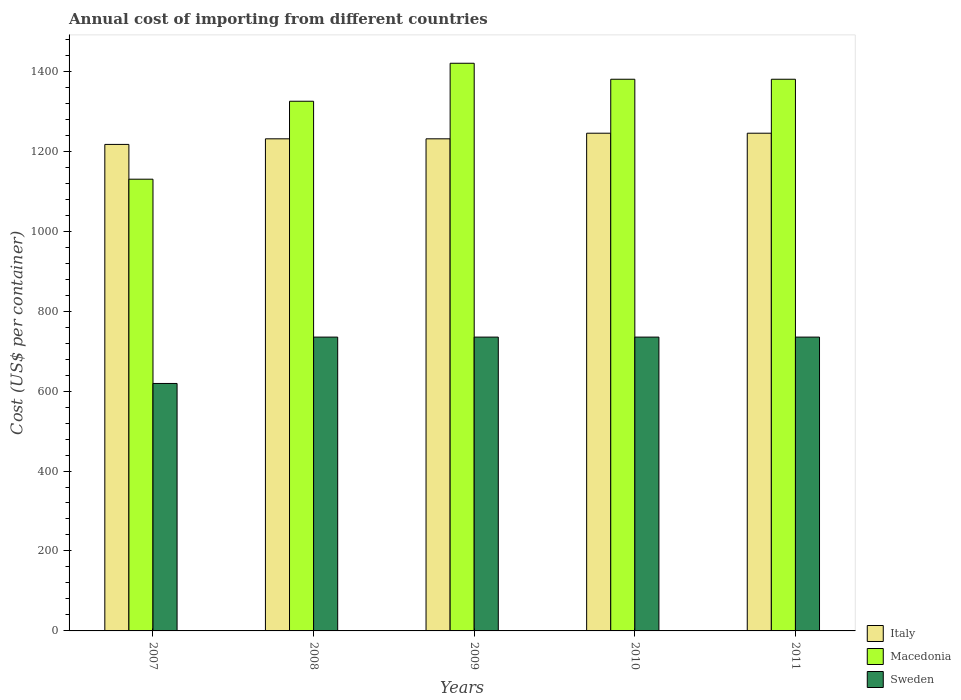How many different coloured bars are there?
Provide a short and direct response. 3. How many groups of bars are there?
Your answer should be very brief. 5. Are the number of bars per tick equal to the number of legend labels?
Provide a short and direct response. Yes. Are the number of bars on each tick of the X-axis equal?
Make the answer very short. Yes. How many bars are there on the 3rd tick from the left?
Your answer should be very brief. 3. How many bars are there on the 3rd tick from the right?
Offer a terse response. 3. What is the label of the 4th group of bars from the left?
Give a very brief answer. 2010. What is the total annual cost of importing in Sweden in 2011?
Make the answer very short. 735. Across all years, what is the maximum total annual cost of importing in Italy?
Your answer should be very brief. 1245. Across all years, what is the minimum total annual cost of importing in Macedonia?
Ensure brevity in your answer.  1130. In which year was the total annual cost of importing in Macedonia maximum?
Offer a very short reply. 2009. In which year was the total annual cost of importing in Macedonia minimum?
Your answer should be compact. 2007. What is the total total annual cost of importing in Sweden in the graph?
Provide a succinct answer. 3559. What is the difference between the total annual cost of importing in Macedonia in 2008 and that in 2009?
Give a very brief answer. -95. What is the difference between the total annual cost of importing in Macedonia in 2007 and the total annual cost of importing in Sweden in 2010?
Offer a terse response. 395. What is the average total annual cost of importing in Sweden per year?
Your response must be concise. 711.8. In the year 2011, what is the difference between the total annual cost of importing in Italy and total annual cost of importing in Macedonia?
Your answer should be very brief. -135. In how many years, is the total annual cost of importing in Macedonia greater than 1200 US$?
Keep it short and to the point. 4. What is the ratio of the total annual cost of importing in Italy in 2008 to that in 2011?
Your answer should be compact. 0.99. What is the difference between the highest and the second highest total annual cost of importing in Italy?
Ensure brevity in your answer.  0. What is the difference between the highest and the lowest total annual cost of importing in Macedonia?
Ensure brevity in your answer.  290. In how many years, is the total annual cost of importing in Macedonia greater than the average total annual cost of importing in Macedonia taken over all years?
Your answer should be very brief. 3. Is the sum of the total annual cost of importing in Macedonia in 2009 and 2010 greater than the maximum total annual cost of importing in Sweden across all years?
Provide a succinct answer. Yes. What does the 2nd bar from the left in 2010 represents?
Offer a very short reply. Macedonia. What does the 2nd bar from the right in 2010 represents?
Make the answer very short. Macedonia. Is it the case that in every year, the sum of the total annual cost of importing in Macedonia and total annual cost of importing in Italy is greater than the total annual cost of importing in Sweden?
Offer a very short reply. Yes. How many years are there in the graph?
Your answer should be compact. 5. Are the values on the major ticks of Y-axis written in scientific E-notation?
Your answer should be very brief. No. Does the graph contain any zero values?
Your response must be concise. No. Does the graph contain grids?
Offer a terse response. No. What is the title of the graph?
Your answer should be compact. Annual cost of importing from different countries. What is the label or title of the Y-axis?
Your answer should be compact. Cost (US$ per container). What is the Cost (US$ per container) in Italy in 2007?
Keep it short and to the point. 1217. What is the Cost (US$ per container) in Macedonia in 2007?
Offer a very short reply. 1130. What is the Cost (US$ per container) in Sweden in 2007?
Ensure brevity in your answer.  619. What is the Cost (US$ per container) in Italy in 2008?
Provide a succinct answer. 1231. What is the Cost (US$ per container) in Macedonia in 2008?
Your answer should be very brief. 1325. What is the Cost (US$ per container) in Sweden in 2008?
Provide a short and direct response. 735. What is the Cost (US$ per container) in Italy in 2009?
Your response must be concise. 1231. What is the Cost (US$ per container) of Macedonia in 2009?
Ensure brevity in your answer.  1420. What is the Cost (US$ per container) of Sweden in 2009?
Ensure brevity in your answer.  735. What is the Cost (US$ per container) of Italy in 2010?
Keep it short and to the point. 1245. What is the Cost (US$ per container) of Macedonia in 2010?
Offer a very short reply. 1380. What is the Cost (US$ per container) in Sweden in 2010?
Your answer should be very brief. 735. What is the Cost (US$ per container) of Italy in 2011?
Offer a terse response. 1245. What is the Cost (US$ per container) in Macedonia in 2011?
Keep it short and to the point. 1380. What is the Cost (US$ per container) in Sweden in 2011?
Provide a succinct answer. 735. Across all years, what is the maximum Cost (US$ per container) of Italy?
Make the answer very short. 1245. Across all years, what is the maximum Cost (US$ per container) of Macedonia?
Provide a short and direct response. 1420. Across all years, what is the maximum Cost (US$ per container) in Sweden?
Give a very brief answer. 735. Across all years, what is the minimum Cost (US$ per container) of Italy?
Make the answer very short. 1217. Across all years, what is the minimum Cost (US$ per container) in Macedonia?
Keep it short and to the point. 1130. Across all years, what is the minimum Cost (US$ per container) in Sweden?
Keep it short and to the point. 619. What is the total Cost (US$ per container) of Italy in the graph?
Your answer should be very brief. 6169. What is the total Cost (US$ per container) of Macedonia in the graph?
Provide a short and direct response. 6635. What is the total Cost (US$ per container) of Sweden in the graph?
Offer a very short reply. 3559. What is the difference between the Cost (US$ per container) in Macedonia in 2007 and that in 2008?
Provide a succinct answer. -195. What is the difference between the Cost (US$ per container) in Sweden in 2007 and that in 2008?
Provide a short and direct response. -116. What is the difference between the Cost (US$ per container) in Macedonia in 2007 and that in 2009?
Provide a short and direct response. -290. What is the difference between the Cost (US$ per container) of Sweden in 2007 and that in 2009?
Make the answer very short. -116. What is the difference between the Cost (US$ per container) of Italy in 2007 and that in 2010?
Offer a terse response. -28. What is the difference between the Cost (US$ per container) in Macedonia in 2007 and that in 2010?
Offer a very short reply. -250. What is the difference between the Cost (US$ per container) of Sweden in 2007 and that in 2010?
Your answer should be very brief. -116. What is the difference between the Cost (US$ per container) of Italy in 2007 and that in 2011?
Keep it short and to the point. -28. What is the difference between the Cost (US$ per container) of Macedonia in 2007 and that in 2011?
Your answer should be compact. -250. What is the difference between the Cost (US$ per container) in Sweden in 2007 and that in 2011?
Keep it short and to the point. -116. What is the difference between the Cost (US$ per container) of Macedonia in 2008 and that in 2009?
Provide a succinct answer. -95. What is the difference between the Cost (US$ per container) of Macedonia in 2008 and that in 2010?
Keep it short and to the point. -55. What is the difference between the Cost (US$ per container) in Sweden in 2008 and that in 2010?
Your response must be concise. 0. What is the difference between the Cost (US$ per container) in Macedonia in 2008 and that in 2011?
Provide a succinct answer. -55. What is the difference between the Cost (US$ per container) in Italy in 2009 and that in 2011?
Offer a terse response. -14. What is the difference between the Cost (US$ per container) in Macedonia in 2009 and that in 2011?
Give a very brief answer. 40. What is the difference between the Cost (US$ per container) of Italy in 2010 and that in 2011?
Offer a very short reply. 0. What is the difference between the Cost (US$ per container) in Macedonia in 2010 and that in 2011?
Your answer should be very brief. 0. What is the difference between the Cost (US$ per container) of Sweden in 2010 and that in 2011?
Provide a succinct answer. 0. What is the difference between the Cost (US$ per container) in Italy in 2007 and the Cost (US$ per container) in Macedonia in 2008?
Make the answer very short. -108. What is the difference between the Cost (US$ per container) in Italy in 2007 and the Cost (US$ per container) in Sweden in 2008?
Provide a short and direct response. 482. What is the difference between the Cost (US$ per container) in Macedonia in 2007 and the Cost (US$ per container) in Sweden in 2008?
Offer a very short reply. 395. What is the difference between the Cost (US$ per container) in Italy in 2007 and the Cost (US$ per container) in Macedonia in 2009?
Provide a short and direct response. -203. What is the difference between the Cost (US$ per container) in Italy in 2007 and the Cost (US$ per container) in Sweden in 2009?
Provide a succinct answer. 482. What is the difference between the Cost (US$ per container) in Macedonia in 2007 and the Cost (US$ per container) in Sweden in 2009?
Your response must be concise. 395. What is the difference between the Cost (US$ per container) in Italy in 2007 and the Cost (US$ per container) in Macedonia in 2010?
Keep it short and to the point. -163. What is the difference between the Cost (US$ per container) of Italy in 2007 and the Cost (US$ per container) of Sweden in 2010?
Keep it short and to the point. 482. What is the difference between the Cost (US$ per container) of Macedonia in 2007 and the Cost (US$ per container) of Sweden in 2010?
Keep it short and to the point. 395. What is the difference between the Cost (US$ per container) in Italy in 2007 and the Cost (US$ per container) in Macedonia in 2011?
Offer a terse response. -163. What is the difference between the Cost (US$ per container) in Italy in 2007 and the Cost (US$ per container) in Sweden in 2011?
Provide a short and direct response. 482. What is the difference between the Cost (US$ per container) in Macedonia in 2007 and the Cost (US$ per container) in Sweden in 2011?
Give a very brief answer. 395. What is the difference between the Cost (US$ per container) of Italy in 2008 and the Cost (US$ per container) of Macedonia in 2009?
Offer a terse response. -189. What is the difference between the Cost (US$ per container) in Italy in 2008 and the Cost (US$ per container) in Sweden in 2009?
Ensure brevity in your answer.  496. What is the difference between the Cost (US$ per container) in Macedonia in 2008 and the Cost (US$ per container) in Sweden in 2009?
Offer a very short reply. 590. What is the difference between the Cost (US$ per container) in Italy in 2008 and the Cost (US$ per container) in Macedonia in 2010?
Your response must be concise. -149. What is the difference between the Cost (US$ per container) of Italy in 2008 and the Cost (US$ per container) of Sweden in 2010?
Your answer should be very brief. 496. What is the difference between the Cost (US$ per container) in Macedonia in 2008 and the Cost (US$ per container) in Sweden in 2010?
Keep it short and to the point. 590. What is the difference between the Cost (US$ per container) in Italy in 2008 and the Cost (US$ per container) in Macedonia in 2011?
Give a very brief answer. -149. What is the difference between the Cost (US$ per container) of Italy in 2008 and the Cost (US$ per container) of Sweden in 2011?
Offer a very short reply. 496. What is the difference between the Cost (US$ per container) of Macedonia in 2008 and the Cost (US$ per container) of Sweden in 2011?
Ensure brevity in your answer.  590. What is the difference between the Cost (US$ per container) of Italy in 2009 and the Cost (US$ per container) of Macedonia in 2010?
Make the answer very short. -149. What is the difference between the Cost (US$ per container) of Italy in 2009 and the Cost (US$ per container) of Sweden in 2010?
Your response must be concise. 496. What is the difference between the Cost (US$ per container) in Macedonia in 2009 and the Cost (US$ per container) in Sweden in 2010?
Make the answer very short. 685. What is the difference between the Cost (US$ per container) in Italy in 2009 and the Cost (US$ per container) in Macedonia in 2011?
Offer a terse response. -149. What is the difference between the Cost (US$ per container) in Italy in 2009 and the Cost (US$ per container) in Sweden in 2011?
Make the answer very short. 496. What is the difference between the Cost (US$ per container) in Macedonia in 2009 and the Cost (US$ per container) in Sweden in 2011?
Keep it short and to the point. 685. What is the difference between the Cost (US$ per container) in Italy in 2010 and the Cost (US$ per container) in Macedonia in 2011?
Provide a short and direct response. -135. What is the difference between the Cost (US$ per container) of Italy in 2010 and the Cost (US$ per container) of Sweden in 2011?
Keep it short and to the point. 510. What is the difference between the Cost (US$ per container) of Macedonia in 2010 and the Cost (US$ per container) of Sweden in 2011?
Your answer should be very brief. 645. What is the average Cost (US$ per container) in Italy per year?
Ensure brevity in your answer.  1233.8. What is the average Cost (US$ per container) of Macedonia per year?
Keep it short and to the point. 1327. What is the average Cost (US$ per container) of Sweden per year?
Provide a succinct answer. 711.8. In the year 2007, what is the difference between the Cost (US$ per container) of Italy and Cost (US$ per container) of Sweden?
Your answer should be compact. 598. In the year 2007, what is the difference between the Cost (US$ per container) of Macedonia and Cost (US$ per container) of Sweden?
Your response must be concise. 511. In the year 2008, what is the difference between the Cost (US$ per container) of Italy and Cost (US$ per container) of Macedonia?
Provide a succinct answer. -94. In the year 2008, what is the difference between the Cost (US$ per container) in Italy and Cost (US$ per container) in Sweden?
Make the answer very short. 496. In the year 2008, what is the difference between the Cost (US$ per container) of Macedonia and Cost (US$ per container) of Sweden?
Give a very brief answer. 590. In the year 2009, what is the difference between the Cost (US$ per container) in Italy and Cost (US$ per container) in Macedonia?
Offer a terse response. -189. In the year 2009, what is the difference between the Cost (US$ per container) in Italy and Cost (US$ per container) in Sweden?
Offer a very short reply. 496. In the year 2009, what is the difference between the Cost (US$ per container) in Macedonia and Cost (US$ per container) in Sweden?
Ensure brevity in your answer.  685. In the year 2010, what is the difference between the Cost (US$ per container) in Italy and Cost (US$ per container) in Macedonia?
Keep it short and to the point. -135. In the year 2010, what is the difference between the Cost (US$ per container) in Italy and Cost (US$ per container) in Sweden?
Ensure brevity in your answer.  510. In the year 2010, what is the difference between the Cost (US$ per container) in Macedonia and Cost (US$ per container) in Sweden?
Your response must be concise. 645. In the year 2011, what is the difference between the Cost (US$ per container) in Italy and Cost (US$ per container) in Macedonia?
Provide a short and direct response. -135. In the year 2011, what is the difference between the Cost (US$ per container) of Italy and Cost (US$ per container) of Sweden?
Provide a succinct answer. 510. In the year 2011, what is the difference between the Cost (US$ per container) of Macedonia and Cost (US$ per container) of Sweden?
Your answer should be compact. 645. What is the ratio of the Cost (US$ per container) of Macedonia in 2007 to that in 2008?
Offer a terse response. 0.85. What is the ratio of the Cost (US$ per container) of Sweden in 2007 to that in 2008?
Your answer should be very brief. 0.84. What is the ratio of the Cost (US$ per container) in Italy in 2007 to that in 2009?
Ensure brevity in your answer.  0.99. What is the ratio of the Cost (US$ per container) in Macedonia in 2007 to that in 2009?
Offer a terse response. 0.8. What is the ratio of the Cost (US$ per container) of Sweden in 2007 to that in 2009?
Provide a succinct answer. 0.84. What is the ratio of the Cost (US$ per container) of Italy in 2007 to that in 2010?
Your response must be concise. 0.98. What is the ratio of the Cost (US$ per container) in Macedonia in 2007 to that in 2010?
Provide a short and direct response. 0.82. What is the ratio of the Cost (US$ per container) of Sweden in 2007 to that in 2010?
Your answer should be very brief. 0.84. What is the ratio of the Cost (US$ per container) of Italy in 2007 to that in 2011?
Give a very brief answer. 0.98. What is the ratio of the Cost (US$ per container) in Macedonia in 2007 to that in 2011?
Give a very brief answer. 0.82. What is the ratio of the Cost (US$ per container) of Sweden in 2007 to that in 2011?
Make the answer very short. 0.84. What is the ratio of the Cost (US$ per container) of Macedonia in 2008 to that in 2009?
Offer a very short reply. 0.93. What is the ratio of the Cost (US$ per container) of Sweden in 2008 to that in 2009?
Your answer should be very brief. 1. What is the ratio of the Cost (US$ per container) of Macedonia in 2008 to that in 2010?
Your response must be concise. 0.96. What is the ratio of the Cost (US$ per container) of Sweden in 2008 to that in 2010?
Provide a succinct answer. 1. What is the ratio of the Cost (US$ per container) of Macedonia in 2008 to that in 2011?
Provide a succinct answer. 0.96. What is the ratio of the Cost (US$ per container) in Italy in 2009 to that in 2011?
Offer a terse response. 0.99. What is the ratio of the Cost (US$ per container) in Macedonia in 2009 to that in 2011?
Provide a short and direct response. 1.03. What is the ratio of the Cost (US$ per container) of Macedonia in 2010 to that in 2011?
Provide a short and direct response. 1. What is the ratio of the Cost (US$ per container) in Sweden in 2010 to that in 2011?
Ensure brevity in your answer.  1. What is the difference between the highest and the lowest Cost (US$ per container) of Macedonia?
Offer a terse response. 290. What is the difference between the highest and the lowest Cost (US$ per container) of Sweden?
Offer a very short reply. 116. 